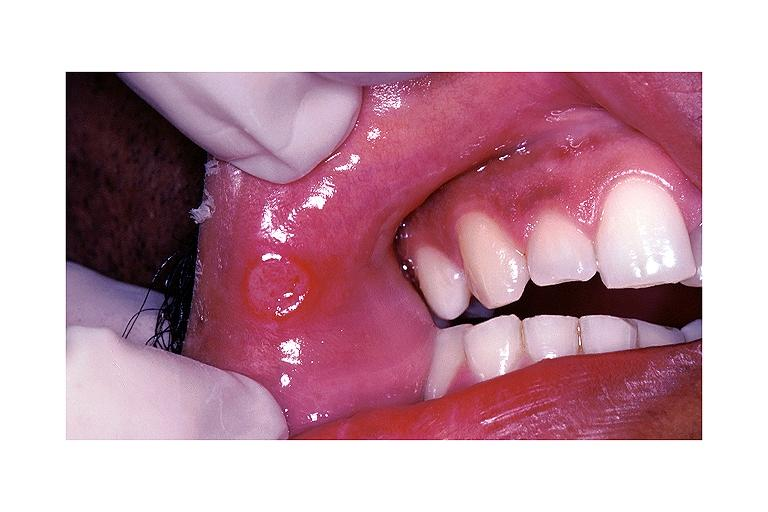what does this image show?
Answer the question using a single word or phrase. Aphthous ulcer 